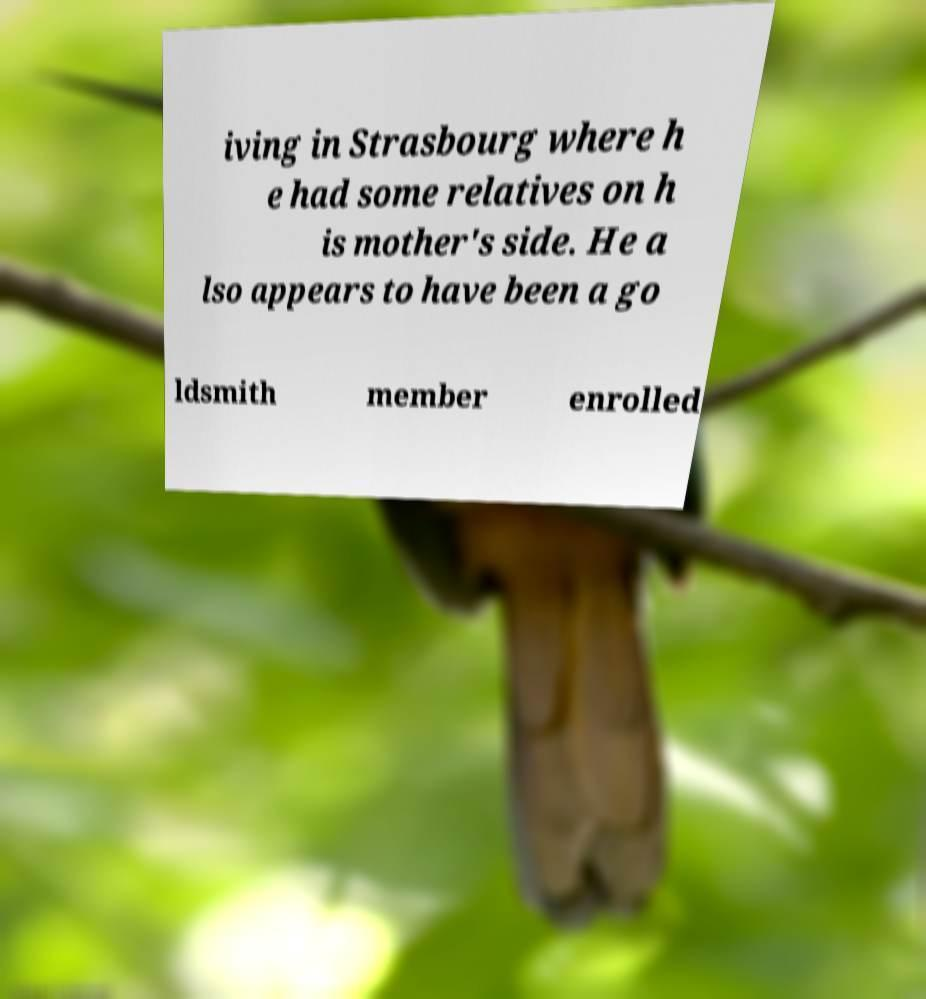Please identify and transcribe the text found in this image. iving in Strasbourg where h e had some relatives on h is mother's side. He a lso appears to have been a go ldsmith member enrolled 